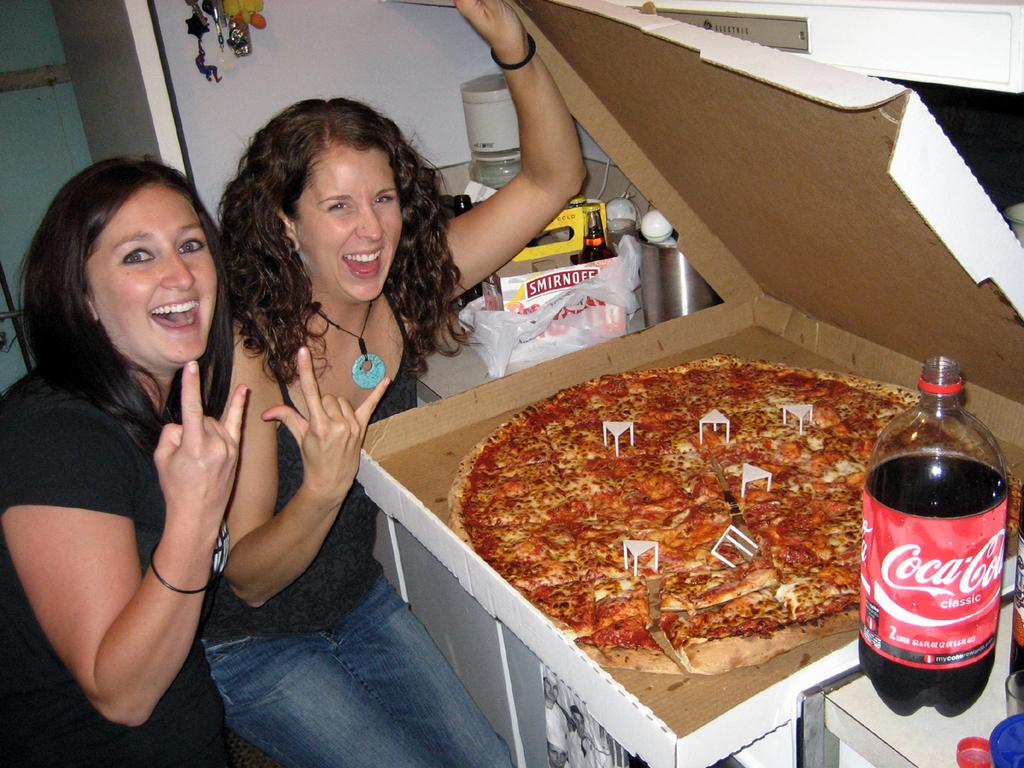What type of food is visible in the image? There is a pizza in the image. What beverage can be seen in the image? There is a juice bottle in the image. How many people are present in the image? There are two persons in the image. What are the two persons wearing? The two persons are wearing black t-shirts. What type of territory is being claimed by the pizza in the image? The pizza is not claiming any territory in the image; it is simply a food item. 